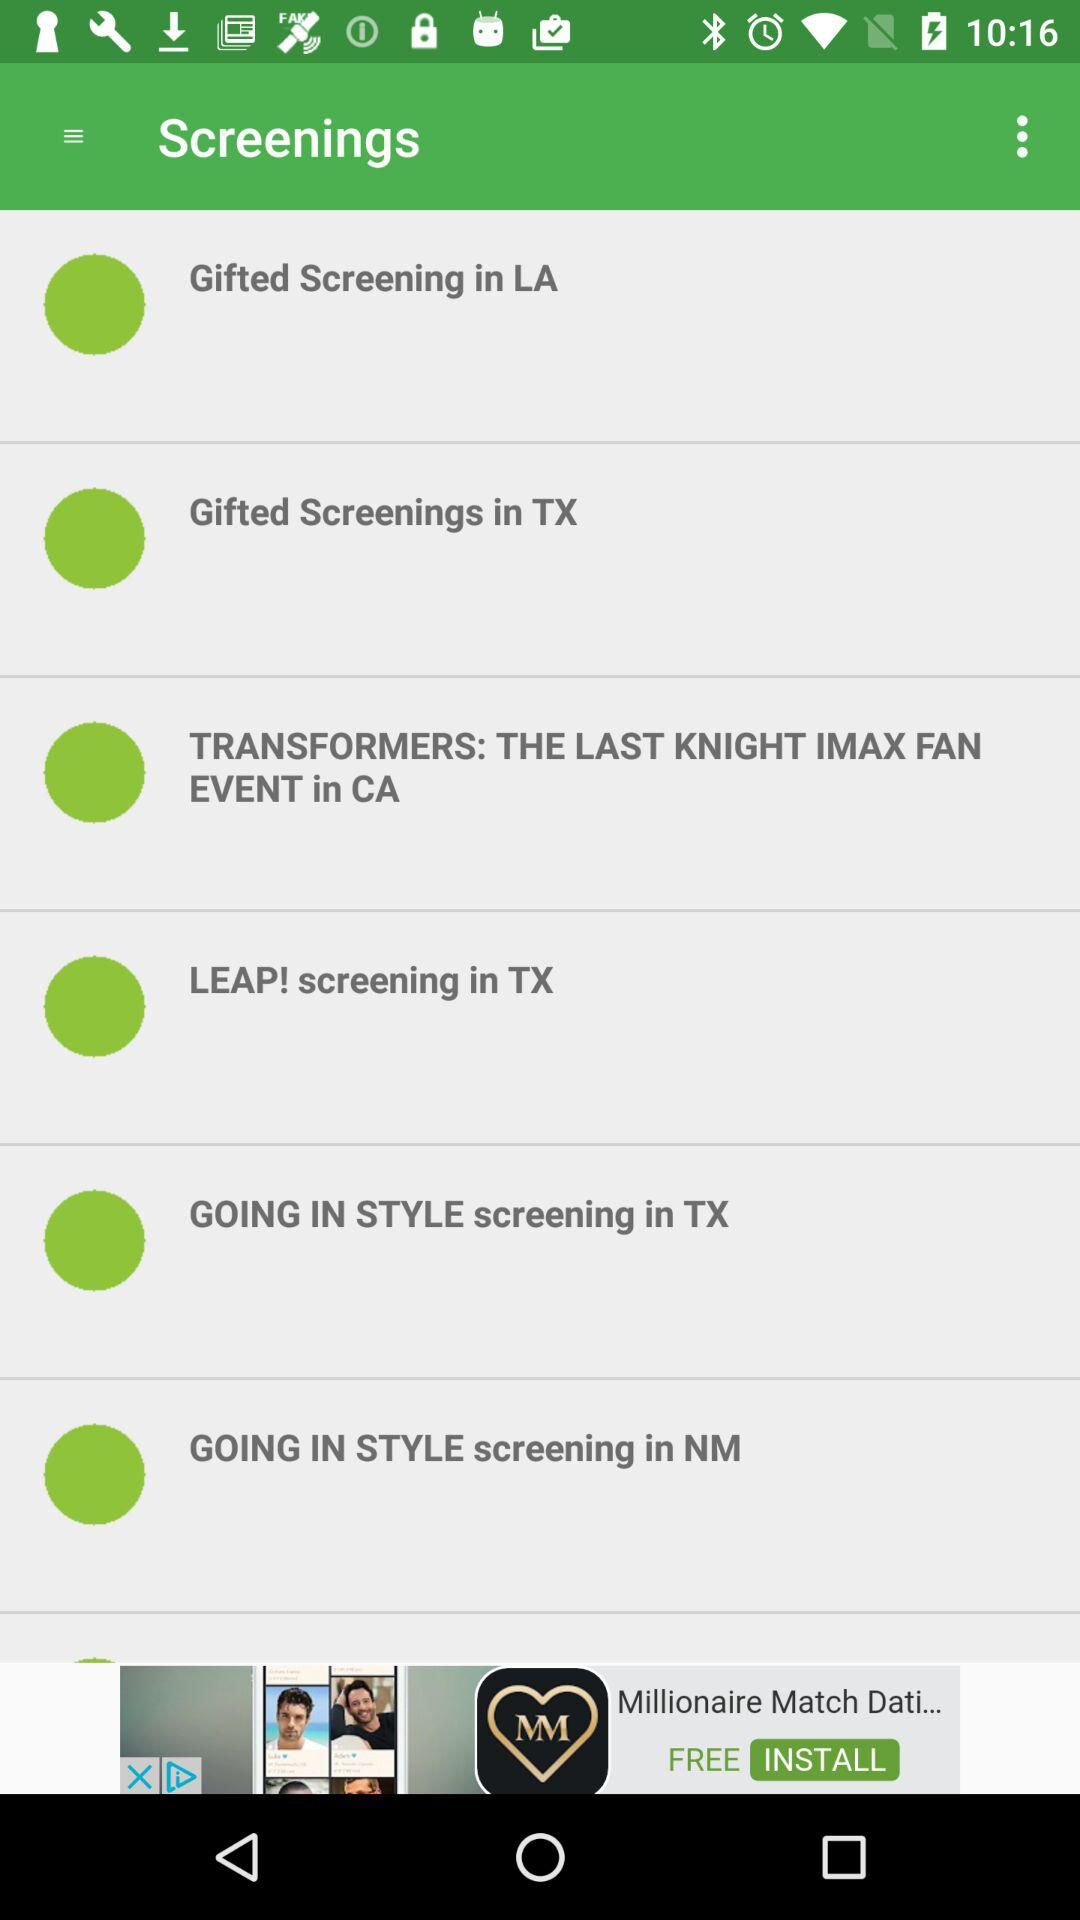How many screenings are in Texas?
Answer the question using a single word or phrase. 3 